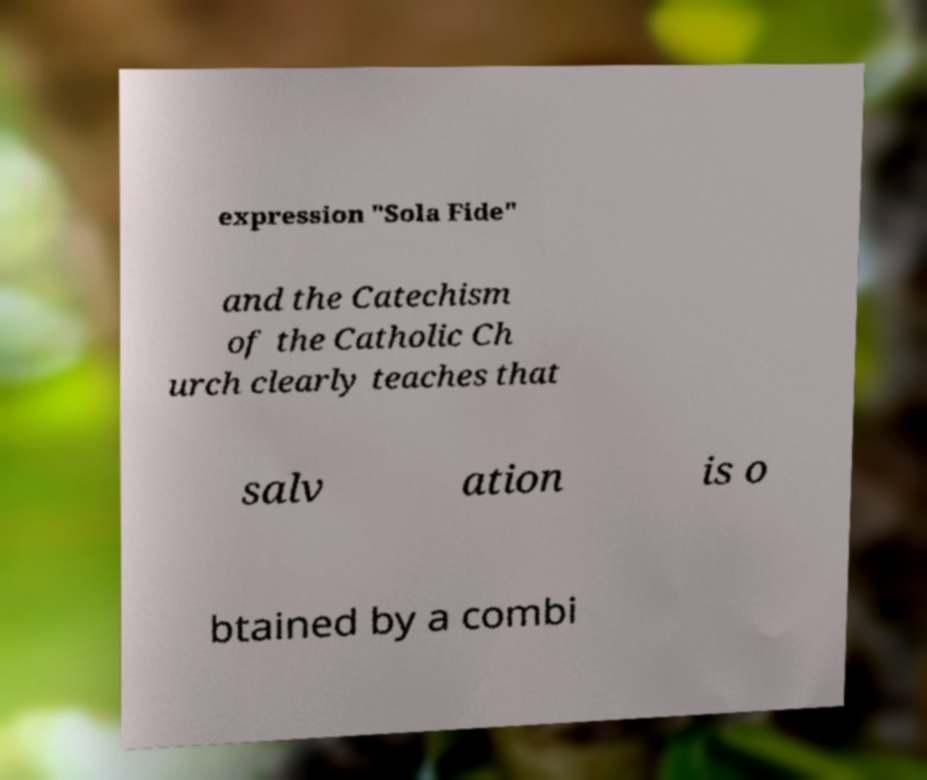Can you accurately transcribe the text from the provided image for me? expression "Sola Fide" and the Catechism of the Catholic Ch urch clearly teaches that salv ation is o btained by a combi 